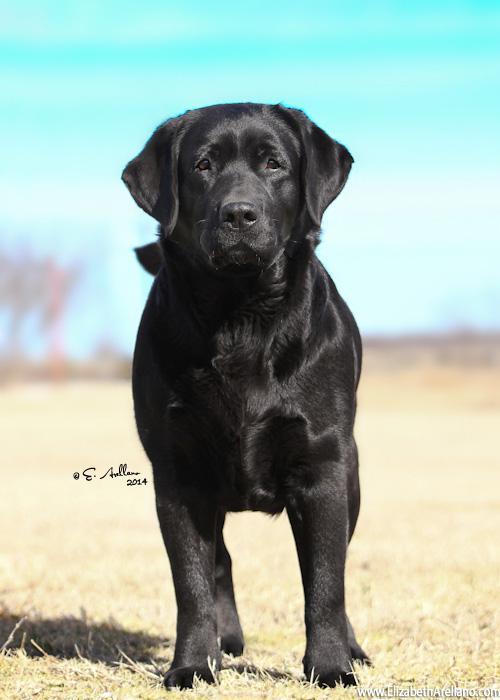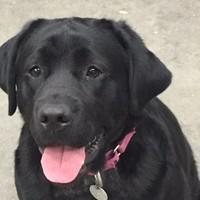The first image is the image on the left, the second image is the image on the right. For the images shown, is this caption "One dog is wearing a collar and sitting." true? Answer yes or no. Yes. The first image is the image on the left, the second image is the image on the right. Evaluate the accuracy of this statement regarding the images: "Only black labrador retrievers are shown, and one dog is in a reclining pose on something soft, and at least one dog wears a collar.". Is it true? Answer yes or no. No. 